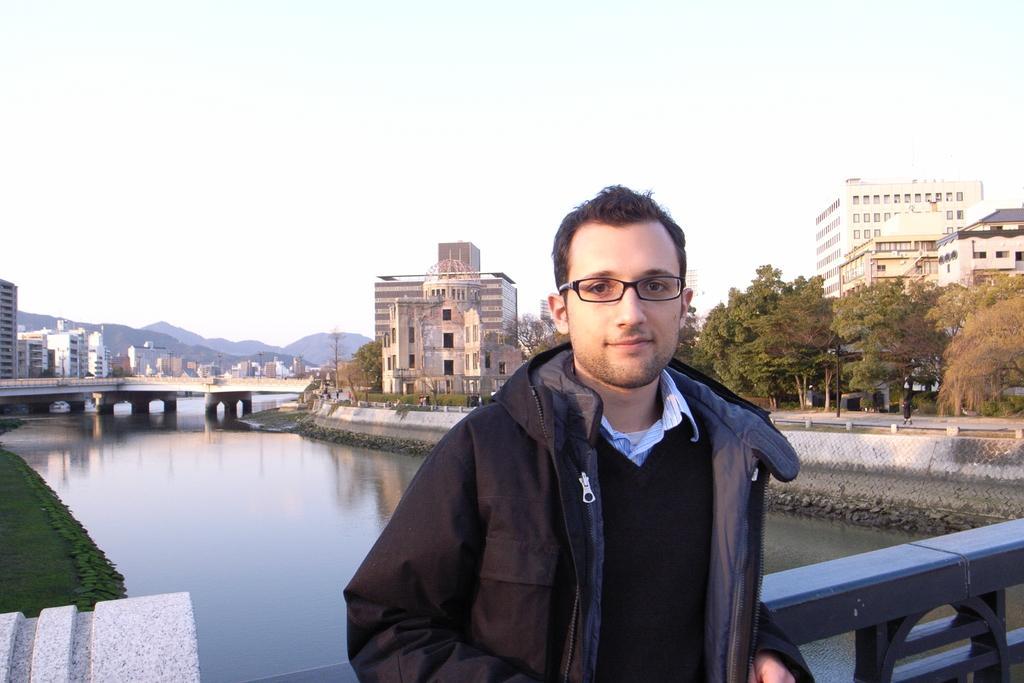Can you describe this image briefly? In the center of the image there is a person standing on the bridge. On the right side of the image we can see trees, buildings, road and pole. On the left side of the image we can see bridgewater, grass, buildings,hills. In the background there are trees, building and sky. 